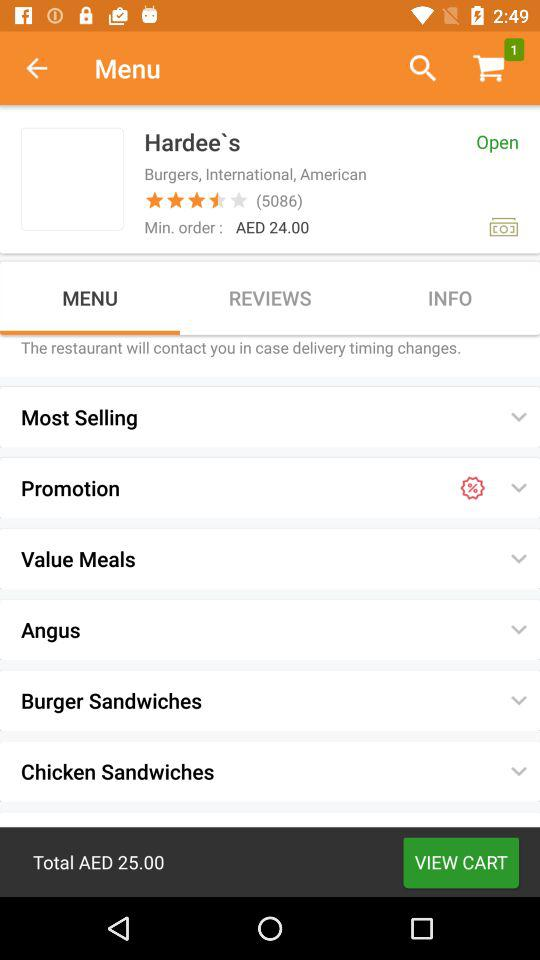How many stars are given by customers out of 5 stars? The star rating is "3.5 stars". 